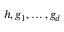Convert formula to latex. <formula><loc_0><loc_0><loc_500><loc_500>h , g _ { 1 } , \dots , g _ { d }</formula> 